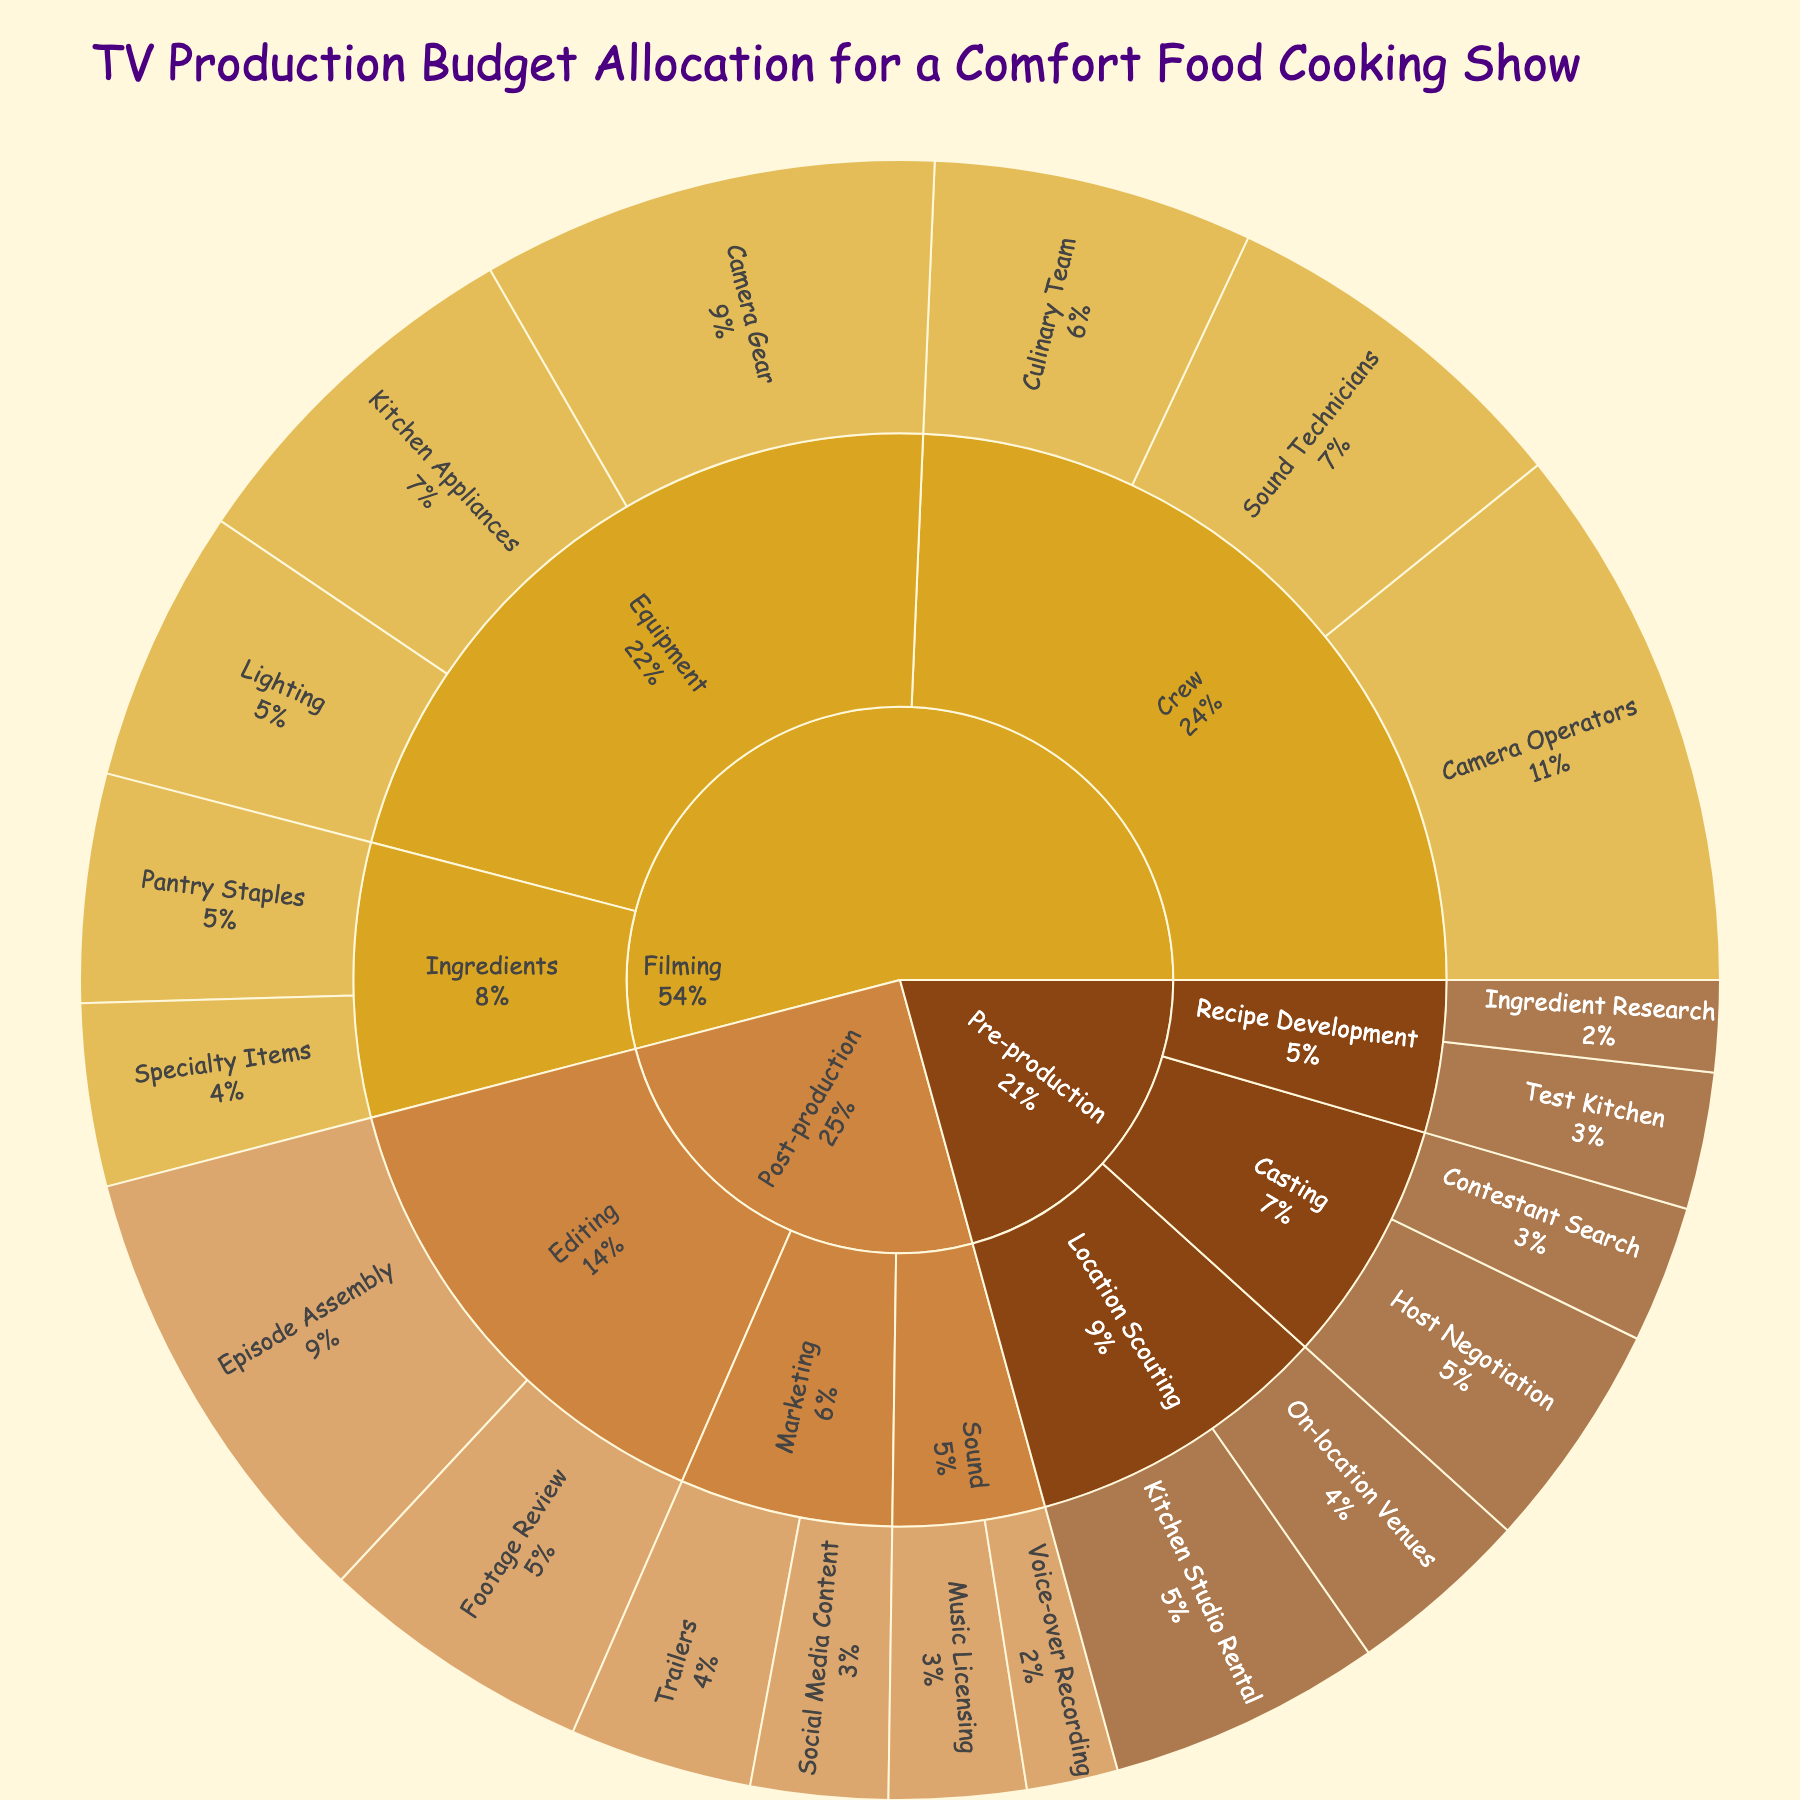what is the total budget allocated for the pre-production phase? To find the total budget for pre-production, sum all the values for the pre-production categories. (15000 + 25000 + 30000 + 20000 + 10000 + 15000)
Answer: 115000 Which budget category has the highest budget allocation within the filming phase? In the filming phase, compare the values of "Equipment", "Crew", and "Ingredients". The Crew category has the highest budget: (Camera Operators: 60000 + Sound Technicians: 40000 + Culinary Team: 35000) = 135000
Answer: Crew What is the combined budget for Editing and Sound in post-production? Sum the budget values for the Editing and Sound categories in post-production (Editing: 30000 + 50000, Sound: 15000 + 10000) for the total. (30000 + 50000 + 15000 + 10000)
Answer: 105000 Which subcategory within the Recipe Development category has a higher budget? Compare the budget values for "Ingredient Research" and "Test Kitchen" under Recipe Development (10000 vs. 15000), The Test Kitchen has a higher budget
Answer: Test Kitchen What proportion of the total budget is allocated to specialty items within ingredients for filming? Calculate the percentage by dividing the budget for specialty items (20000) by the total budget and then multiplying by 100. (20000 / (sum of all values) * 100) = (20000 / 565000 * 100)
Answer: 3.54% Between pre-production and post-production, which phase has a larger total budget allocated? Sum the budgets for each phase and compare, pre-production (115000) vs. post-production (130000), post-production has a larger budget.
Answer: Post-production How much more budget is allocated to camera operators compared to camera gear? Subtract the budget for camera gear (50000) from the budget for camera operators (60000), the difference is (60000 - 50000)
Answer: 10000 Which phase is represented by the light brown color? Based on the color scheme provided, "#DAA520" corresponds to Filming
Answer: Filming 